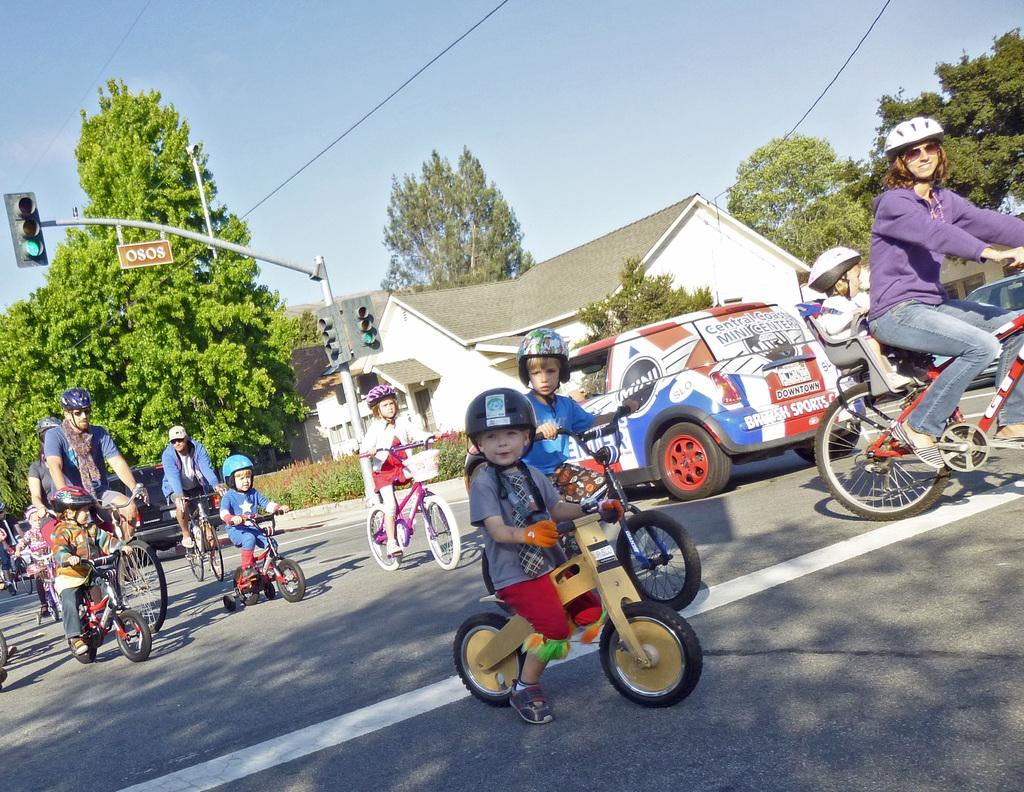What are the people in the image doing? The people in the image are riding bicycles. What safety precaution are the people taking while riding bicycles? The people are wearing helmets. What type of terrain can be seen in the image? There is grass visible in the image. Are there any vehicles present in the image? Yes, there is a car in the image. What type of structure can be seen in the image? There is a house in the image. What traffic control device is present in the image? There is a traffic signal in the image. What type of vegetation is visible in the image? There are trees in the image. What is visible at the top of the image? The sky is visible at the top of the image. What type of bait is being used by the people riding bicycles in the image? There is no bait present in the image; the people are riding bicycles. How many grips can be seen on the bicycles in the image? The image does not provide enough detail to count the number of grips on the bicycles. 